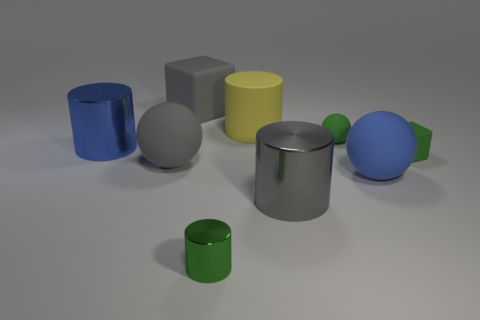Subtract all cyan cylinders. Subtract all brown blocks. How many cylinders are left? 4 Add 1 tiny red cylinders. How many objects exist? 10 Subtract all cylinders. How many objects are left? 5 Add 7 big cyan cylinders. How many big cyan cylinders exist? 7 Subtract 1 gray cylinders. How many objects are left? 8 Subtract all small rubber things. Subtract all metal objects. How many objects are left? 4 Add 2 gray rubber balls. How many gray rubber balls are left? 3 